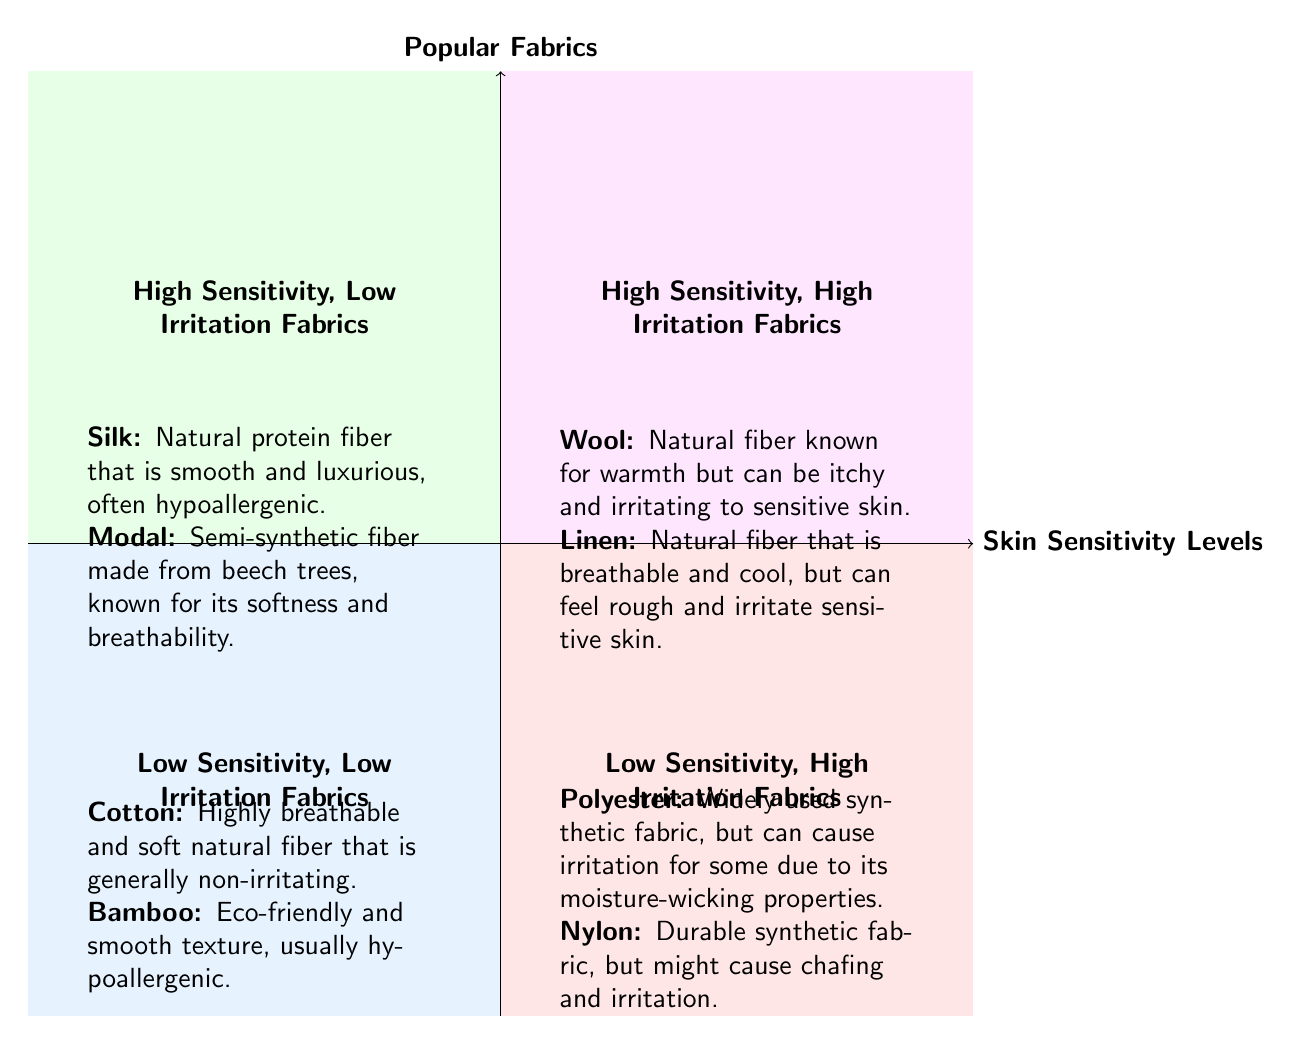What are the two fabrics in the "Low Sensitivity, Low Irritation Fabrics" quadrant? In the quadrant labeled "Low Sensitivity, Low Irritation Fabrics," there are two fabrics listed: Cotton and Bamboo. These are mentioned in the specific section dedicated to this quadrant in the diagram.
Answer: Cotton, Bamboo Which quadrant contains "Silk"? "Silk" is placed in the "High Sensitivity, Low Irritation Fabrics" quadrant. This is determined by locating Silk within the designated fabric descriptions in that specific quadrant of the diagram.
Answer: High Sensitivity, Low Irritation Fabrics How many fabrics are categorized under "High Sensitivity, High Irritation Fabrics"? There are two fabrics listed under the "High Sensitivity, High Irritation Fabrics" quadrant, which are Wool and Linen. This can be noted from the specific section dedicated to this quadrant in the diagram.
Answer: 2 What are the characteristics of Polyester? Polyester is described as a widely used synthetic fabric. It can cause irritation for some individuals due to its moisture-wicking properties. This information can be derived from the details presented in the "Low Sensitivity, High Irritation Fabrics" quadrant.
Answer: Widely used synthetic fabric, can cause irritation Which fabric is known for being hypoallergenic and luxurious? The fabric known for being hypoallergenic and luxurious is Silk. This conclusion is reached by looking at the description associated with Silk in the "High Sensitivity, Low Irritation Fabrics" quadrant of the diagram.
Answer: Silk What are the fabrics listed in the "Low Sensitivity, High Irritation Fabrics" quadrant? The "Low Sensitivity, High Irritation Fabrics" quadrant includes two fabrics: Polyester and Nylon. This can be confirmed by reviewing the content specifically mentioned in that quadrant of the diagram.
Answer: Polyester, Nylon 